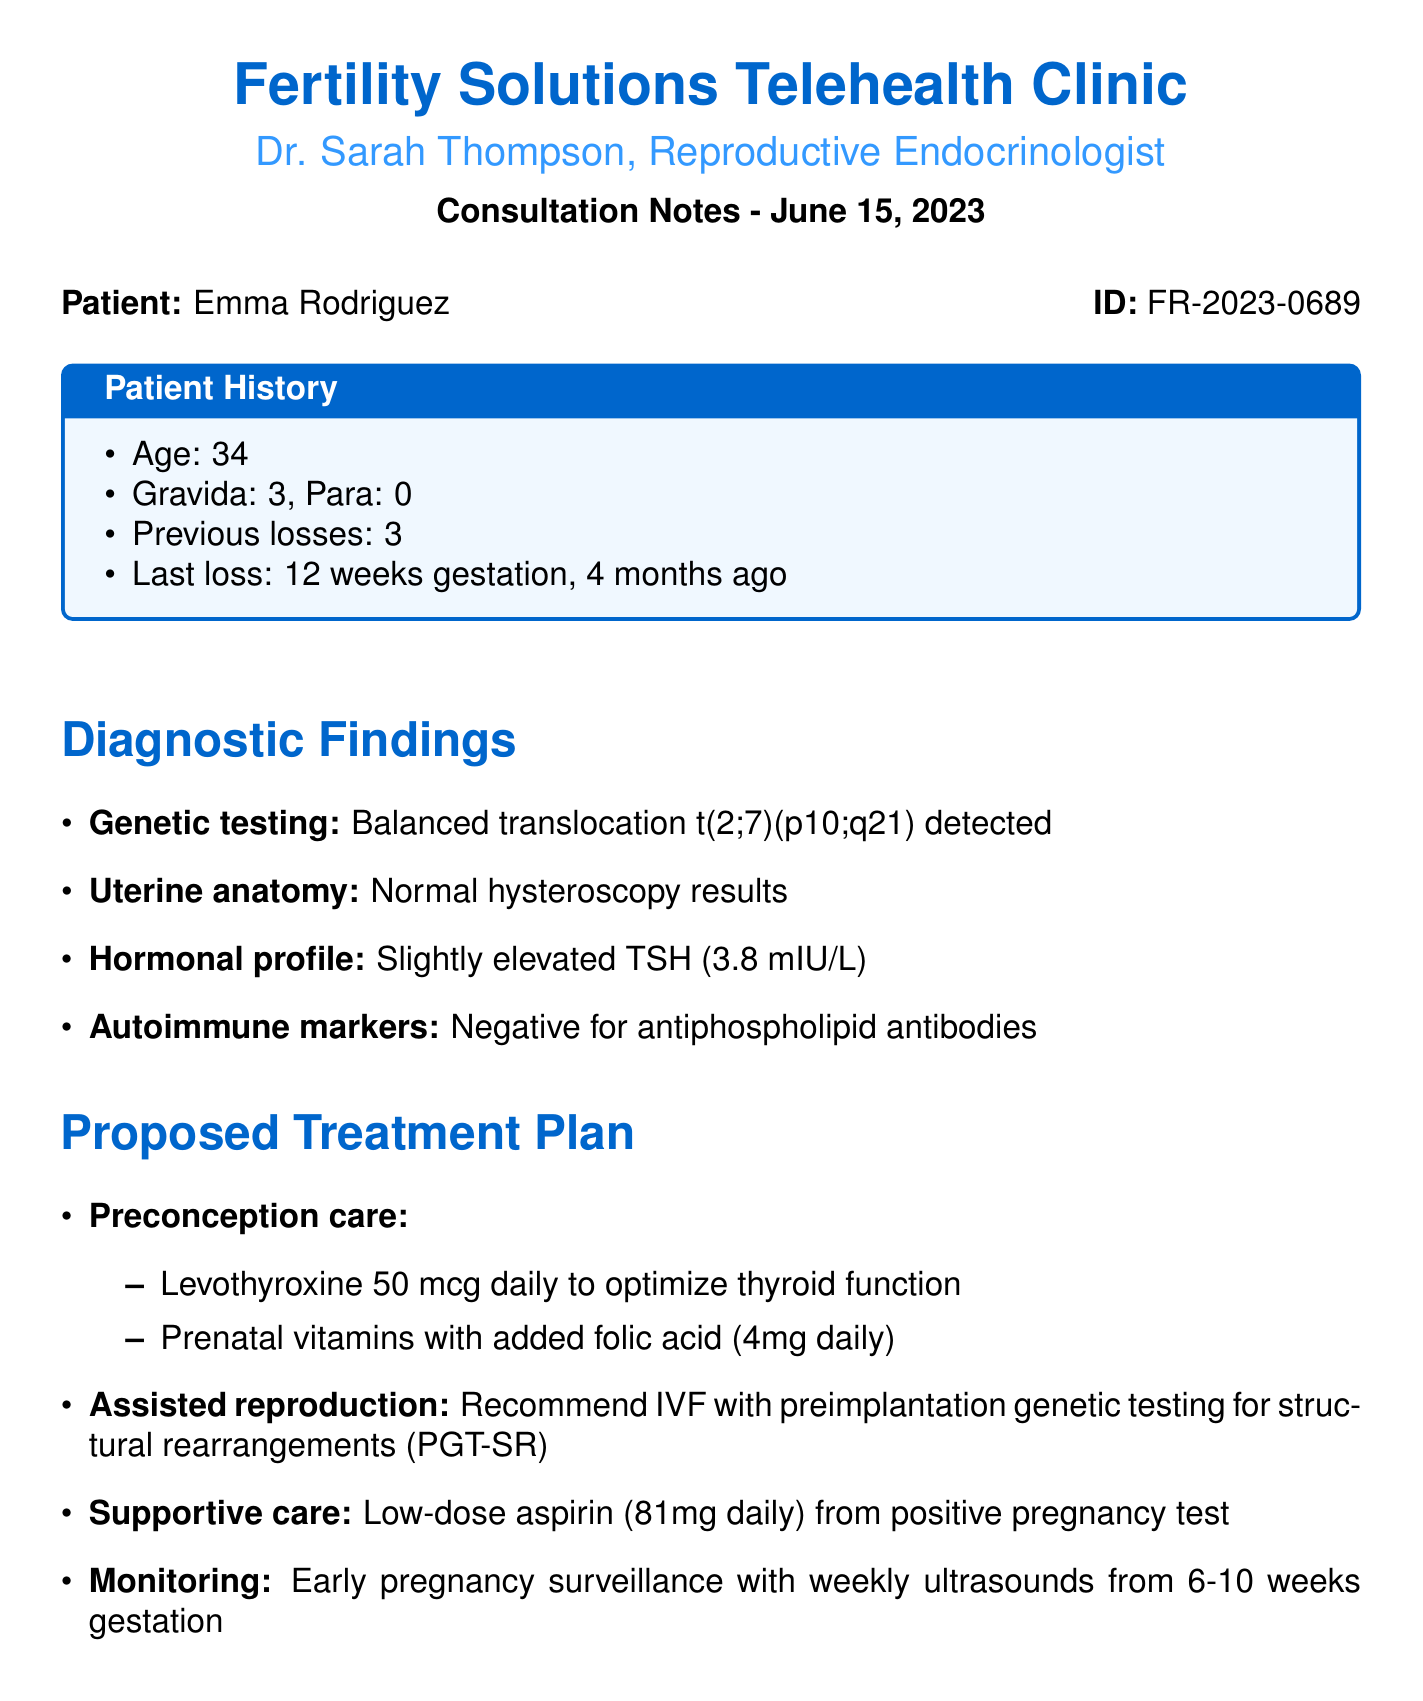What is the patient's age? The patient's age is explicitly stated in the document as part of the patient history section.
Answer: 34 How many previous pregnancy losses does the patient have? The document specifies the number of previous pregnancy losses in the patient history section.
Answer: 3 What is the last loss gestational age? The document provides information about the last pregnancy loss in terms of gestational age within the patient history section.
Answer: 12 weeks What is the proposed dosage of levothyroxine? The document details the proposed treatment plan, specifically mentioning the dosage of levothyroxine.
Answer: 50 mcg daily What genetic condition was detected in the patient? The diagnostic findings mention a specific genetic condition related to the patient.
Answer: Balanced translocation t(2;7)(p10;q21) When is the next appointment scheduled? The follow-up section of the document specifies the date for the patient’s next appointment.
Answer: July 13, 2023 What type of testing is recommended for assisted reproduction? The proposed treatment plan mentions the specific type of genetic testing to be used during assisted reproduction.
Answer: PGT-SR What medication should be started from the positive pregnancy test? The proposed treatment plan indicates a specific medication to be taken after a positive pregnancy test.
Answer: Low-dose aspirin (81mg daily) What was the result of the autoimmune markers test? The document provides the outcome of specific testing related to autoimmune markers in the diagnostic findings section.
Answer: Negative for antiphospholipid antibodies 